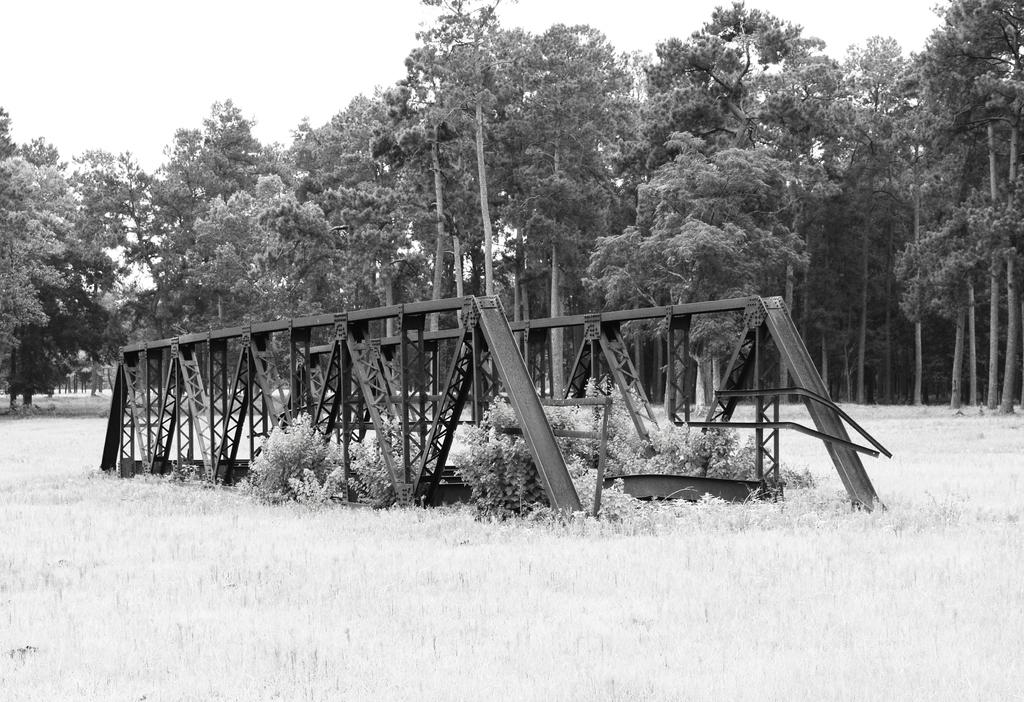What type of vegetation can be seen in the image? There is dry grass, plants, and trees in the image. What is visible at the top of the image? The sky is visible at the top of the image. What type of store can be seen in the image? There is no store present in the image; it features dry grass, plants, trees, and the sky. What route are the plants taking in the image? The plants are not taking any route in the image; they are stationary. 